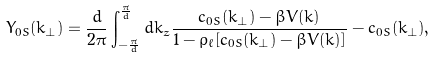<formula> <loc_0><loc_0><loc_500><loc_500>Y _ { 0 S } ( k _ { \perp } ) = \frac { d } { 2 \pi } \int _ { - \frac { \pi } { d } } ^ { \frac { \pi } { d } } d k _ { z } \frac { c _ { 0 S } ( k _ { \perp } ) - \beta V ( { k } ) } { 1 - \rho _ { \ell } [ c _ { 0 S } ( k _ { \perp } ) - \beta V ( { k } ) ] } - c _ { 0 S } ( k _ { \perp } ) ,</formula> 